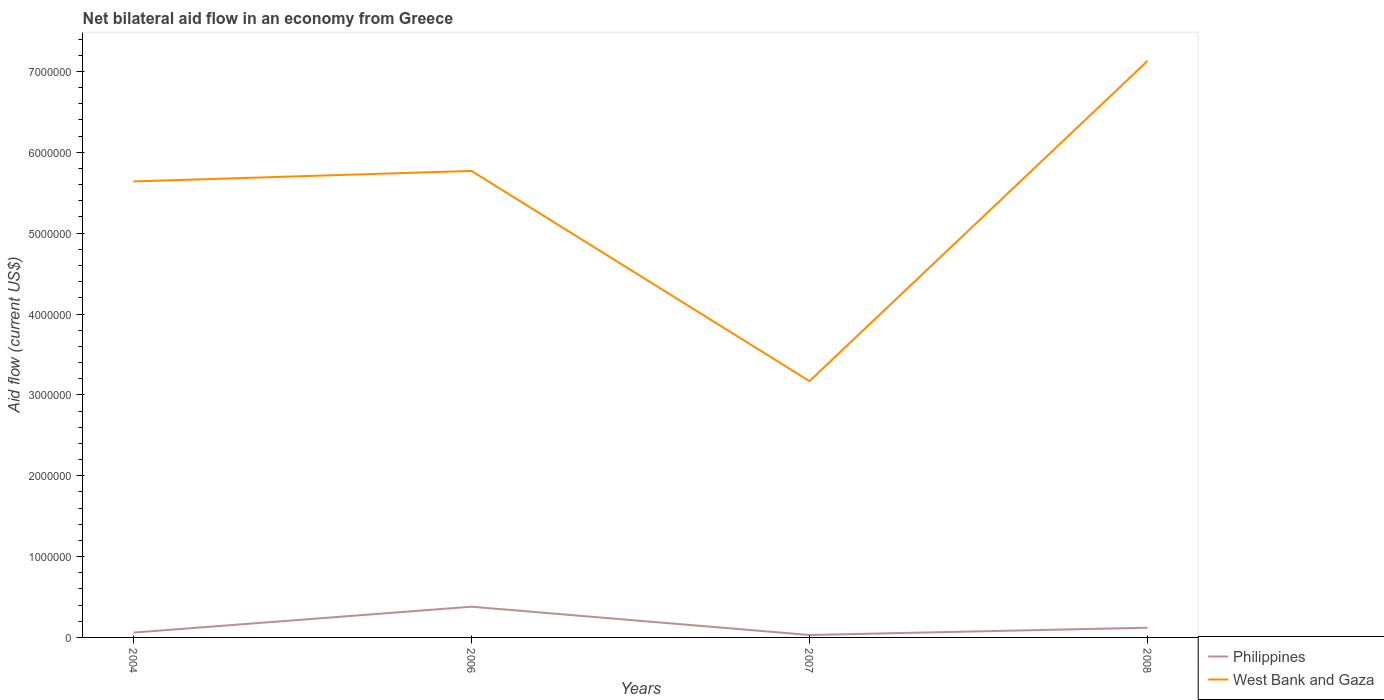How many different coloured lines are there?
Offer a terse response. 2. Is the number of lines equal to the number of legend labels?
Offer a very short reply. Yes. Across all years, what is the maximum net bilateral aid flow in West Bank and Gaza?
Make the answer very short. 3.17e+06. In which year was the net bilateral aid flow in Philippines maximum?
Offer a very short reply. 2007. What is the total net bilateral aid flow in Philippines in the graph?
Give a very brief answer. -6.00e+04. What is the difference between the highest and the second highest net bilateral aid flow in West Bank and Gaza?
Offer a very short reply. 3.96e+06. Is the net bilateral aid flow in Philippines strictly greater than the net bilateral aid flow in West Bank and Gaza over the years?
Your answer should be compact. Yes. How many lines are there?
Your response must be concise. 2. Are the values on the major ticks of Y-axis written in scientific E-notation?
Offer a terse response. No. Where does the legend appear in the graph?
Provide a short and direct response. Bottom right. How many legend labels are there?
Give a very brief answer. 2. What is the title of the graph?
Your response must be concise. Net bilateral aid flow in an economy from Greece. What is the Aid flow (current US$) in Philippines in 2004?
Your response must be concise. 6.00e+04. What is the Aid flow (current US$) in West Bank and Gaza in 2004?
Keep it short and to the point. 5.64e+06. What is the Aid flow (current US$) of Philippines in 2006?
Keep it short and to the point. 3.80e+05. What is the Aid flow (current US$) of West Bank and Gaza in 2006?
Offer a very short reply. 5.77e+06. What is the Aid flow (current US$) in West Bank and Gaza in 2007?
Offer a terse response. 3.17e+06. What is the Aid flow (current US$) of West Bank and Gaza in 2008?
Provide a short and direct response. 7.13e+06. Across all years, what is the maximum Aid flow (current US$) in West Bank and Gaza?
Your answer should be compact. 7.13e+06. Across all years, what is the minimum Aid flow (current US$) in West Bank and Gaza?
Provide a succinct answer. 3.17e+06. What is the total Aid flow (current US$) in Philippines in the graph?
Your response must be concise. 5.90e+05. What is the total Aid flow (current US$) of West Bank and Gaza in the graph?
Offer a terse response. 2.17e+07. What is the difference between the Aid flow (current US$) in Philippines in 2004 and that in 2006?
Your answer should be compact. -3.20e+05. What is the difference between the Aid flow (current US$) in West Bank and Gaza in 2004 and that in 2006?
Provide a succinct answer. -1.30e+05. What is the difference between the Aid flow (current US$) of West Bank and Gaza in 2004 and that in 2007?
Give a very brief answer. 2.47e+06. What is the difference between the Aid flow (current US$) of Philippines in 2004 and that in 2008?
Make the answer very short. -6.00e+04. What is the difference between the Aid flow (current US$) of West Bank and Gaza in 2004 and that in 2008?
Ensure brevity in your answer.  -1.49e+06. What is the difference between the Aid flow (current US$) of West Bank and Gaza in 2006 and that in 2007?
Offer a very short reply. 2.60e+06. What is the difference between the Aid flow (current US$) in Philippines in 2006 and that in 2008?
Your response must be concise. 2.60e+05. What is the difference between the Aid flow (current US$) of West Bank and Gaza in 2006 and that in 2008?
Keep it short and to the point. -1.36e+06. What is the difference between the Aid flow (current US$) in Philippines in 2007 and that in 2008?
Give a very brief answer. -9.00e+04. What is the difference between the Aid flow (current US$) in West Bank and Gaza in 2007 and that in 2008?
Make the answer very short. -3.96e+06. What is the difference between the Aid flow (current US$) in Philippines in 2004 and the Aid flow (current US$) in West Bank and Gaza in 2006?
Provide a succinct answer. -5.71e+06. What is the difference between the Aid flow (current US$) in Philippines in 2004 and the Aid flow (current US$) in West Bank and Gaza in 2007?
Give a very brief answer. -3.11e+06. What is the difference between the Aid flow (current US$) of Philippines in 2004 and the Aid flow (current US$) of West Bank and Gaza in 2008?
Give a very brief answer. -7.07e+06. What is the difference between the Aid flow (current US$) in Philippines in 2006 and the Aid flow (current US$) in West Bank and Gaza in 2007?
Give a very brief answer. -2.79e+06. What is the difference between the Aid flow (current US$) of Philippines in 2006 and the Aid flow (current US$) of West Bank and Gaza in 2008?
Keep it short and to the point. -6.75e+06. What is the difference between the Aid flow (current US$) in Philippines in 2007 and the Aid flow (current US$) in West Bank and Gaza in 2008?
Give a very brief answer. -7.10e+06. What is the average Aid flow (current US$) in Philippines per year?
Your answer should be compact. 1.48e+05. What is the average Aid flow (current US$) in West Bank and Gaza per year?
Give a very brief answer. 5.43e+06. In the year 2004, what is the difference between the Aid flow (current US$) in Philippines and Aid flow (current US$) in West Bank and Gaza?
Make the answer very short. -5.58e+06. In the year 2006, what is the difference between the Aid flow (current US$) in Philippines and Aid flow (current US$) in West Bank and Gaza?
Your response must be concise. -5.39e+06. In the year 2007, what is the difference between the Aid flow (current US$) in Philippines and Aid flow (current US$) in West Bank and Gaza?
Your answer should be very brief. -3.14e+06. In the year 2008, what is the difference between the Aid flow (current US$) in Philippines and Aid flow (current US$) in West Bank and Gaza?
Offer a terse response. -7.01e+06. What is the ratio of the Aid flow (current US$) of Philippines in 2004 to that in 2006?
Offer a terse response. 0.16. What is the ratio of the Aid flow (current US$) in West Bank and Gaza in 2004 to that in 2006?
Ensure brevity in your answer.  0.98. What is the ratio of the Aid flow (current US$) of Philippines in 2004 to that in 2007?
Keep it short and to the point. 2. What is the ratio of the Aid flow (current US$) in West Bank and Gaza in 2004 to that in 2007?
Offer a terse response. 1.78. What is the ratio of the Aid flow (current US$) of West Bank and Gaza in 2004 to that in 2008?
Provide a succinct answer. 0.79. What is the ratio of the Aid flow (current US$) of Philippines in 2006 to that in 2007?
Ensure brevity in your answer.  12.67. What is the ratio of the Aid flow (current US$) of West Bank and Gaza in 2006 to that in 2007?
Give a very brief answer. 1.82. What is the ratio of the Aid flow (current US$) in Philippines in 2006 to that in 2008?
Your answer should be very brief. 3.17. What is the ratio of the Aid flow (current US$) in West Bank and Gaza in 2006 to that in 2008?
Provide a short and direct response. 0.81. What is the ratio of the Aid flow (current US$) in West Bank and Gaza in 2007 to that in 2008?
Your response must be concise. 0.44. What is the difference between the highest and the second highest Aid flow (current US$) of West Bank and Gaza?
Provide a succinct answer. 1.36e+06. What is the difference between the highest and the lowest Aid flow (current US$) in West Bank and Gaza?
Provide a short and direct response. 3.96e+06. 